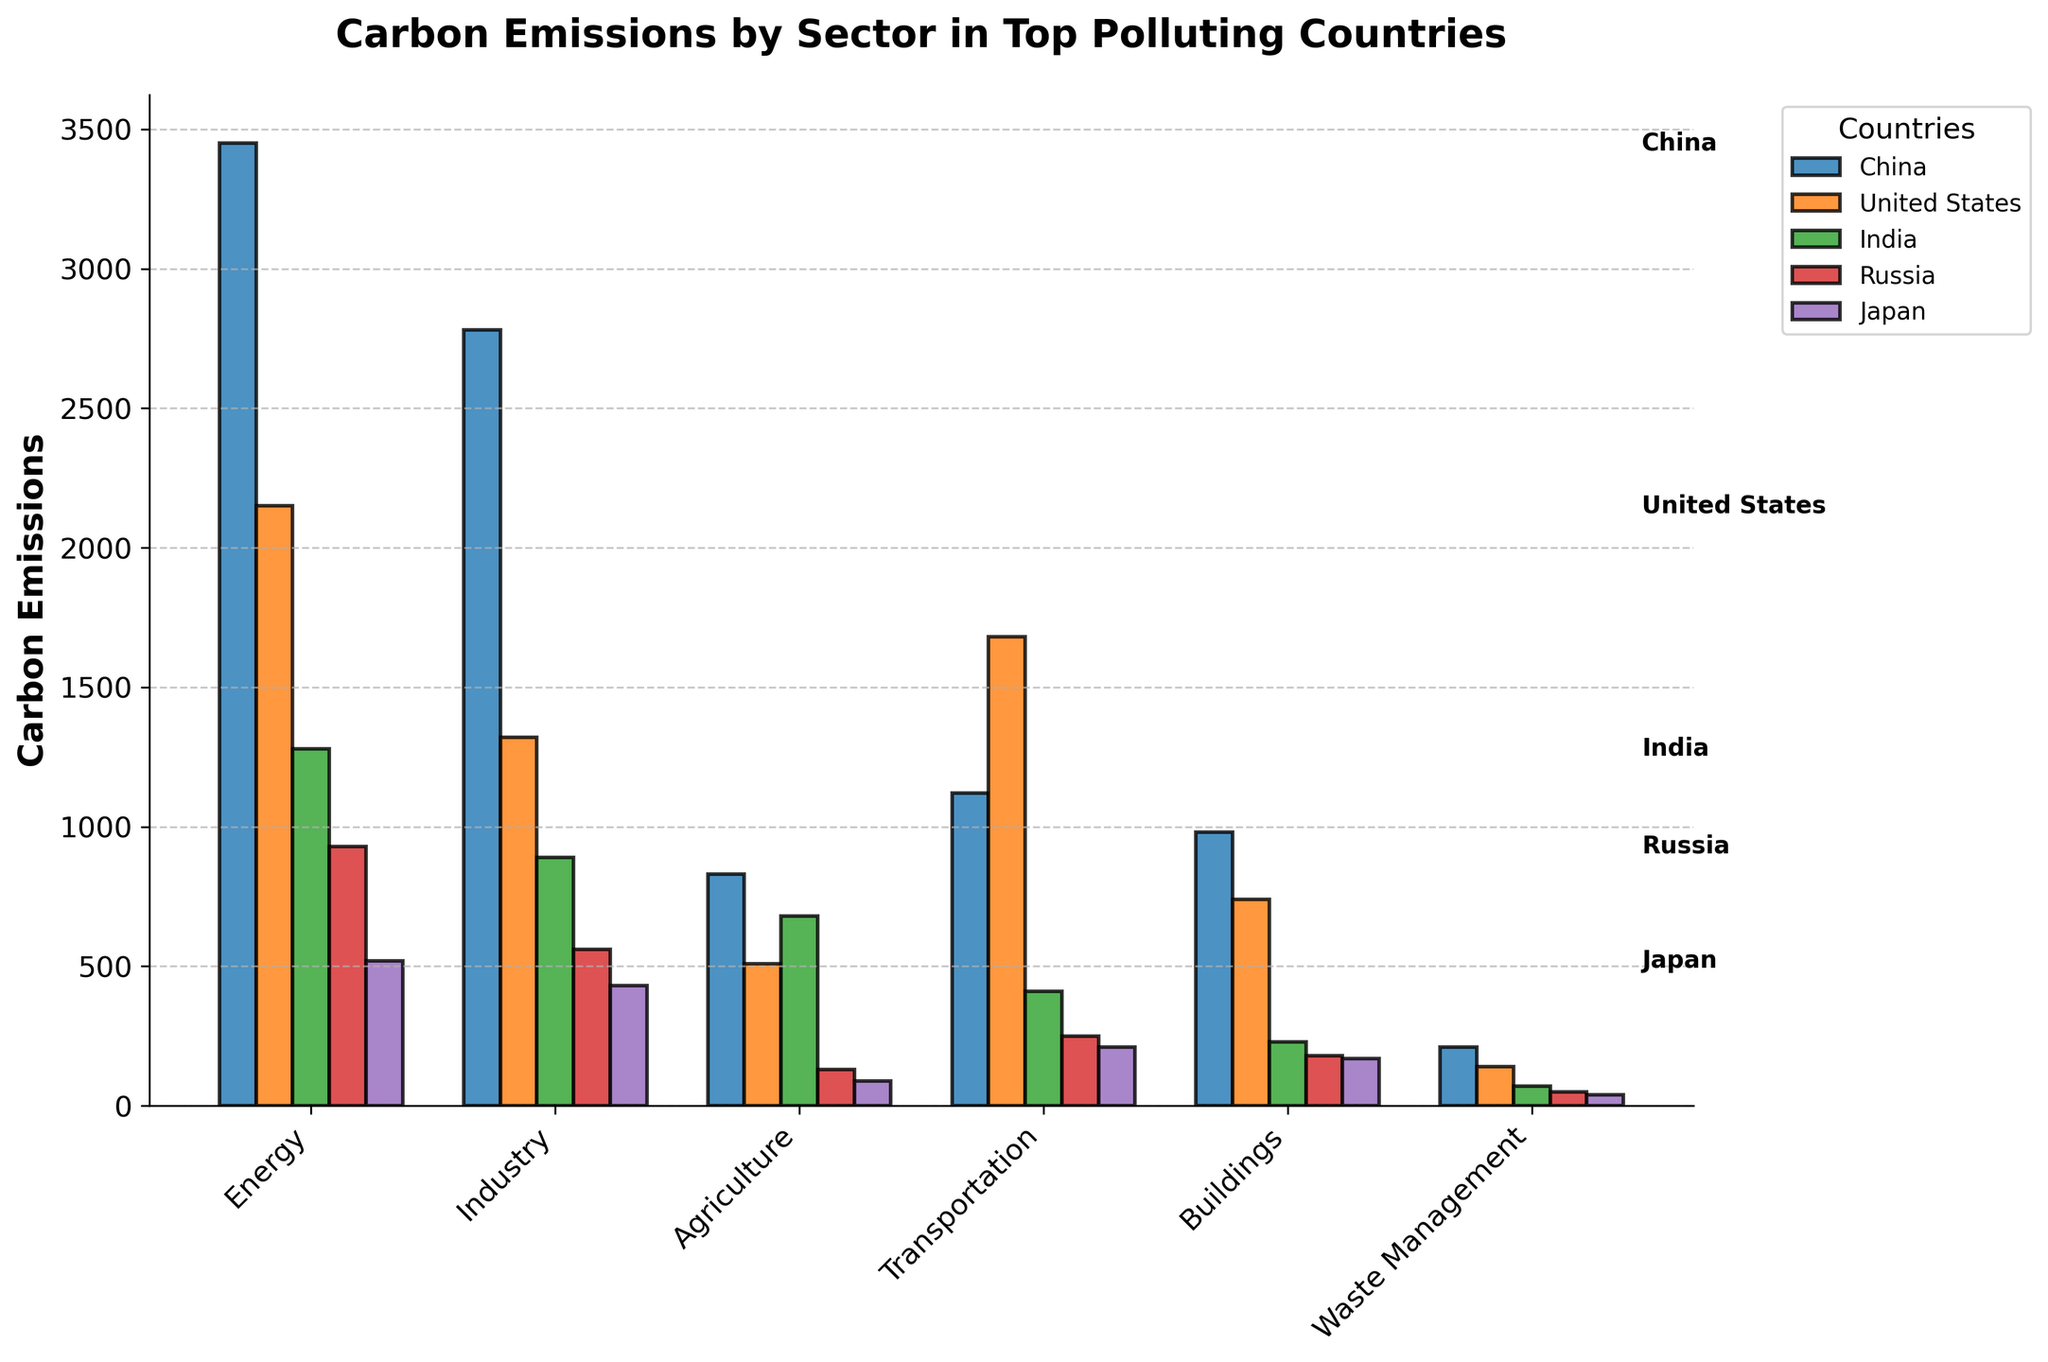Which country has the highest carbon emissions in the Transportation sector? By comparing the heights of the bars representing the Transportation sector across all countries, the United States has the highest bar.
Answer: United States What is the difference in carbon emissions between the Industry sector and the Energy sector in Russia? From the chart, the Industry sector has 560 units and the Energy sector has 930 units of emissions in Russia. The difference is 930 - 560 = 370 units.
Answer: 370 Which country contributes the least to carbon emissions in Agriculture, and by how much? Looking at the bars for the Agriculture sector, Japan has the shortest bar with 90 units of emissions.
Answer: Japan with 90 units Which sector has the highest total carbon emissions across all countries? Summing the heights of the bars for each sector across all countries shows that the Energy sector has the highest total emissions.
Answer: Energy Compare the carbon emissions of India and Japan in the Buildings sector. Which country has higher emissions and by how much? In the Buildings sector, India has 230 units and Japan has 170 units of emissions. India has higher emissions by 230 - 170 = 60 units.
Answer: India by 60 units What is the average carbon emission in the Waste Management sector across all countries? Summing the values for Waste Management sector across all countries (210 + 140 + 70 + 50 + 40) gives 510 units. Dividing by the number of countries (5) gives an average of 510 / 5 = 102 units.
Answer: 102 units Which sector shows the smallest difference between emissions in China and the United States? By examining the differences between China and the United States in each sector, Waste Management has the smallest difference: 210 - 140 = 70 units.
Answer: Waste Management How much higher are the carbon emissions of the Energy sector in China compared to Japan? The Energy sector in China has 3450 units, and in Japan, it has 520 units. The difference is 3450 - 520 = 2930 units.
Answer: 2930 units If you sum the emissions from Agriculture and Waste Management sectors in the United States, is it more or less than the emissions from the Transportation sector in the same country? By how much? Agriculture in the United States is 510 units and Waste Management is 140 units. Summing these gives 510 + 140 = 650 units. The Transportation sector has 1680 units. The difference is 1680 - 650 = 1030 units more in the Transportation sector.
Answer: More by 1030 units 